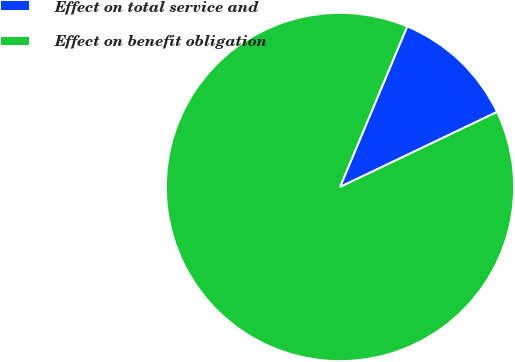Convert chart to OTSL. <chart><loc_0><loc_0><loc_500><loc_500><pie_chart><fcel>Effect on total service and<fcel>Effect on benefit obligation<nl><fcel>11.6%<fcel>88.4%<nl></chart> 